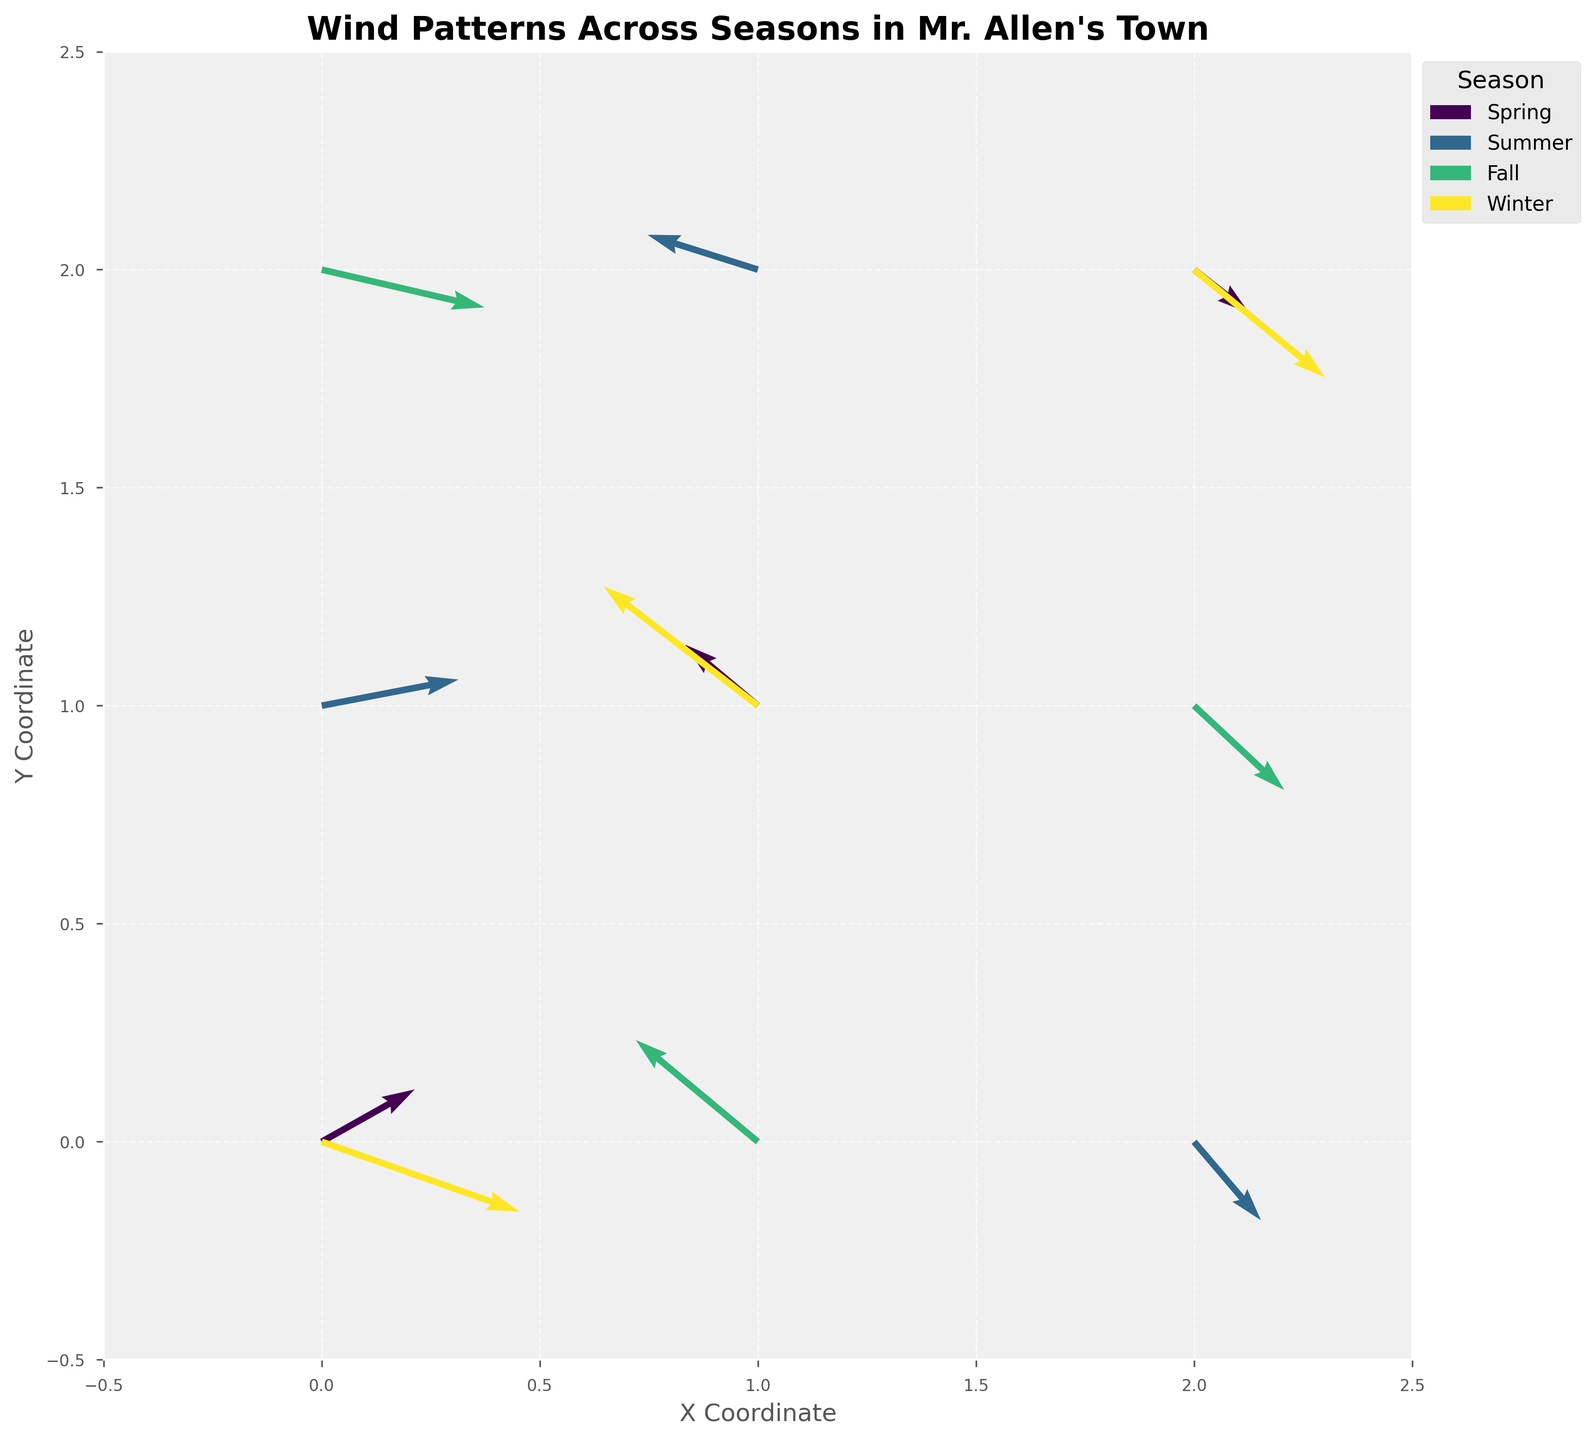what is the title of the plot? The title is written in bold at the top of the figure and provides an overview of what the plot represents. The title for this plot is "Wind Patterns Across Seasons in Mr. Allen's Town".
Answer: Wind Patterns Across Seasons in Mr. Allen's Town Which season appears to have the strongest overall wind pattern? The strength of the wind is indicated by the length of the arrows. The longest arrows seem to be present in the Winter season, suggesting the strongest wind patterns.
Answer: Winter What are the coordinates of the wind data points shown for the Spring season? Observing the quiver plot, the Spring season has arrows originating from three coordinates: (0, 0), (1, 1), and (2, 2).
Answer: (0, 0), (1, 1), and (2, 2) How many unique seasons are depicted in the plot? The legend on the right side of the plot indicates the different seasons. There are four unique seasons: Spring, Summer, Fall, and Winter.
Answer: Four What colors represent the Summer season? Each season is represented by a different color in the plot. The Summer season appears in a shade of green.
Answer: Green Which direction does the wind blow from the point (0, 0) in the Winter? From the figure, the arrow from (0, 0) in Winter points to the right and slightly downwards, meaning the wind direction is southeast.
Answer: Southeast Compare the wind speeds in the Fall and Spring seasons. Which season experiences higher wind variations? The variations in wind speeds can be observed by comparing the lengths of the arrows. By doing this, we can see that Fall has both longer and shorter arrows, indicating a higher variation in wind speeds compared to Spring.
Answer: Fall For the Summer season, which coordinate has the wind blowing in the negative X direction? Examining the arrows in the Summer season, the coordinate (1, 2) has the wind blowing in the negative X direction.
Answer: (1, 2) In which direction is the wind blowing from the point (1, 0) in the Fall season? Looking at the figure, the wind from (1, 0) in Fall is directed towards the upper left, which corresponds to the northwest direction.
Answer: Northwest What's the vertical component (V) of the wind at the coordinate (2, 2) in the Winter season? The V component represents the vertical component of the wind vector. From the dataset, the V value at (2, 2) during Winter is -3.7, indicating that the wind is blowing downward vertically.
Answer: -3.7 